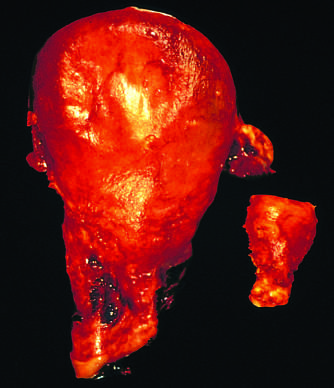was the injurious stimulus removed for postpartum bleeding?
Answer the question using a single word or phrase. No 